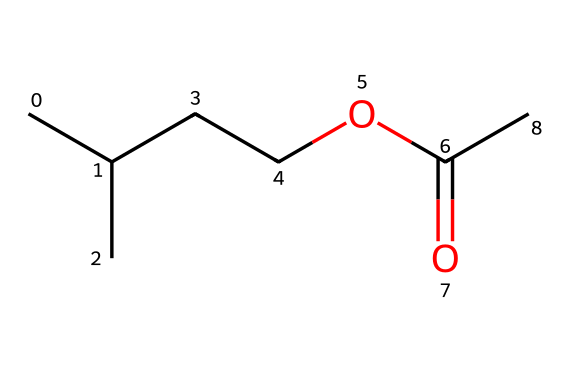What is the common name of this chemical? The chemical represented by the given SMILES is isoamyl acetate, known for its banana-like scent.
Answer: isoamyl acetate How many carbon atoms are in isoamyl acetate? By analyzing the SMILES, there are five carbon atoms explicitly represented (C) in the chain and one carbon in the ester functional group (C=O), totaling to six.
Answer: six How many oxygen atoms are present in isoamyl acetate? The SMILES shows one carbonyl (C=O) and one ether-like oxygen (C-O), amounting to two oxygen atoms in total.
Answer: two What functional group is present in this chemical? The presence of the carbonyl (C=O) bond and the ether-like oxygen (C-O) indicates that isoamyl acetate contains an ester functional group.
Answer: ester Does isoamyl acetate have any double bonds? Yes, there is one double bond in the structure, specifically in the carbonyl (C=O) part of the ester group.
Answer: yes What type of scent does isoamyl acetate typically produce? Isoamyl acetate is known for producing a banana-like scent, making it popular in food flavorings and fragrances.
Answer: banana-like scent Is isoamyl acetate polar or nonpolar? The presence of both the polar carbonyl group and nonpolar hydrocarbon tail suggests that isoamyl acetate exhibits a mix of polar and nonpolar characteristics, but overall it is nonpolar due to its hydrocarbon character.
Answer: nonpolar 